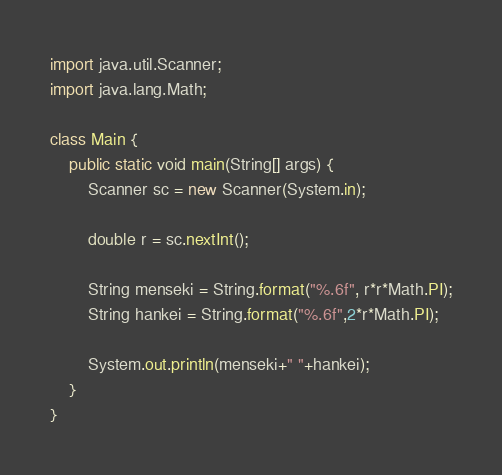Convert code to text. <code><loc_0><loc_0><loc_500><loc_500><_Java_>import java.util.Scanner;
import java.lang.Math;

class Main {
    public static void main(String[] args) {
        Scanner sc = new Scanner(System.in);

        double r = sc.nextInt();

        String menseki = String.format("%.6f", r*r*Math.PI);
        String hankei = String.format("%.6f",2*r*Math.PI);

        System.out.println(menseki+" "+hankei);
    }
}</code> 